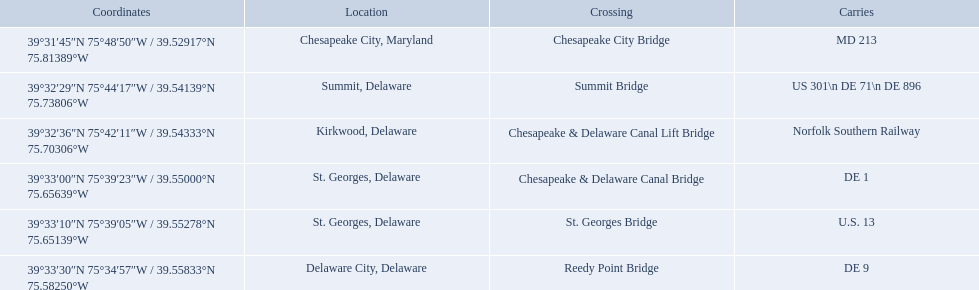What gets carried within the canal? MD 213, US 301\n DE 71\n DE 896, Norfolk Southern Railway, DE 1, U.S. 13, DE 9. Which of those carries de 9? DE 9. To what crossing does that entry correspond? Reedy Point Bridge. What are the names of the major crossings for the chesapeake and delaware canal? Chesapeake City Bridge, Summit Bridge, Chesapeake & Delaware Canal Lift Bridge, Chesapeake & Delaware Canal Bridge, St. Georges Bridge, Reedy Point Bridge. What routes are carried by these crossings? MD 213, US 301\n DE 71\n DE 896, Norfolk Southern Railway, DE 1, U.S. 13, DE 9. Which of those routes is comprised of more than one route? US 301\n DE 71\n DE 896. Which crossing carries those routes? Summit Bridge. 